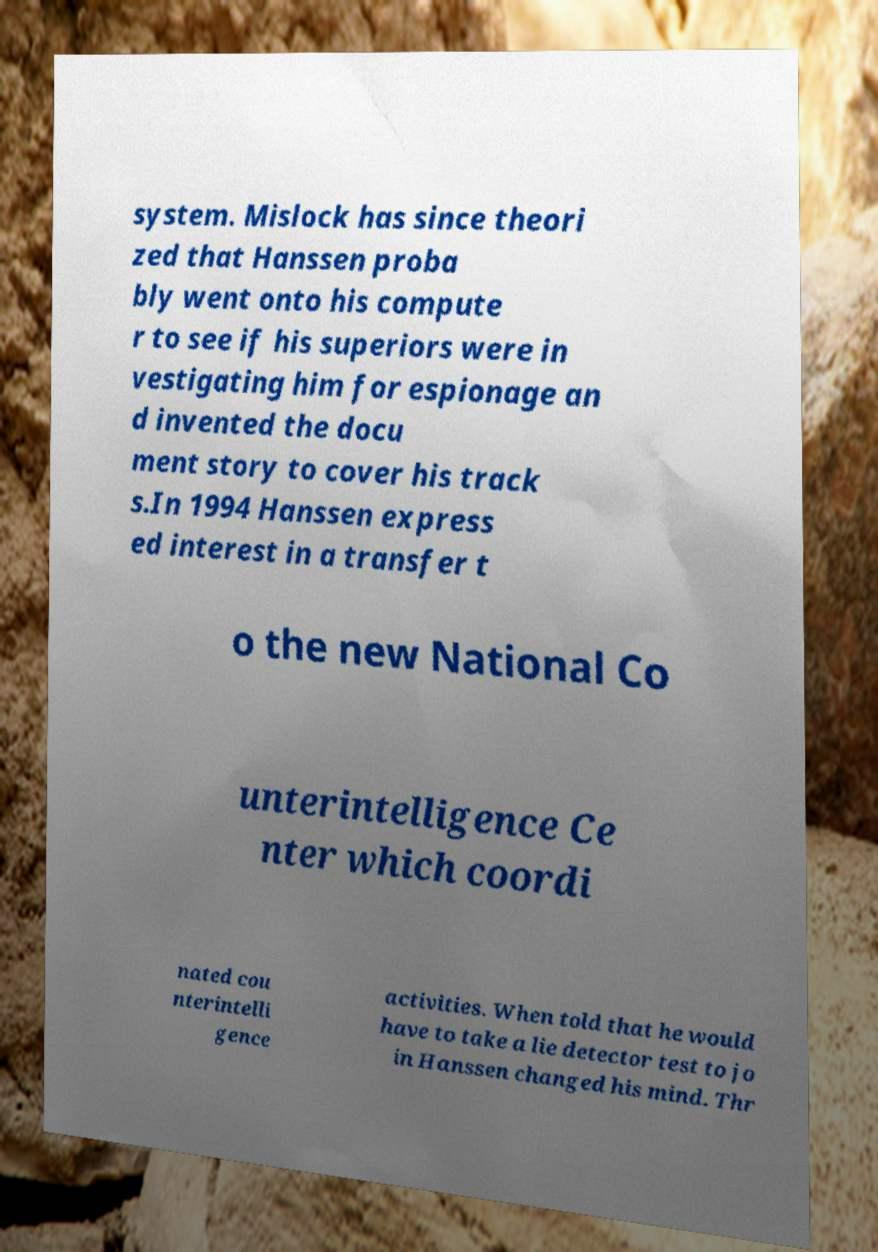Can you accurately transcribe the text from the provided image for me? system. Mislock has since theori zed that Hanssen proba bly went onto his compute r to see if his superiors were in vestigating him for espionage an d invented the docu ment story to cover his track s.In 1994 Hanssen express ed interest in a transfer t o the new National Co unterintelligence Ce nter which coordi nated cou nterintelli gence activities. When told that he would have to take a lie detector test to jo in Hanssen changed his mind. Thr 